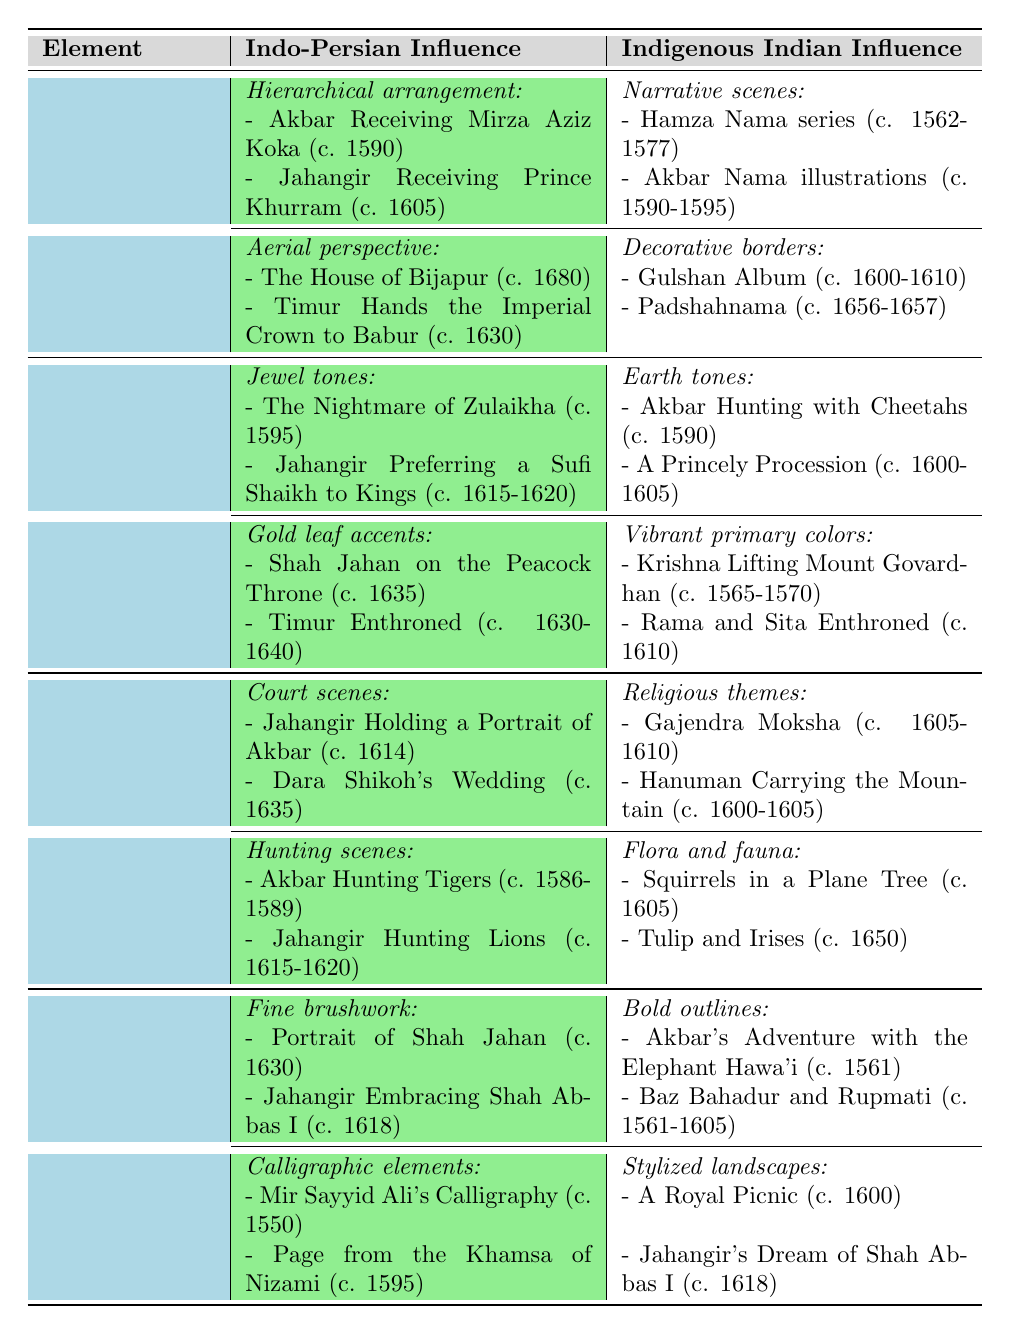What are the main Indo-Persian influences in the composition of Mughal miniature paintings? The table lists two key features under Indo-Persian influence for the composition element: hierarchical arrangement and aerial perspective. These features include specific examples of paintings showcasing these influences.
Answer: Hierarchical arrangement and aerial perspective List one example of indigenous Indian influence in the color palette. The indigenous Indian influence in the color palette includes two features: earth tones and vibrant primary colors. One example under earth tones is "Akbar Hunting with Cheetahs (c. 1590)."
Answer: Akbar Hunting with Cheetahs (c. 1590) How many features of artistic techniques are mentioned in total for both influences? The table lists two features under Indo-Persian influence (fine brushwork and calligraphic elements) and two features under indigenous Indian influence (bold outlines and stylized landscapes), totaling four.
Answer: Four Are there any examples of hunting scenes in indigenous Indian influences? According to the table, indigenous Indian influences in subject matter include religious themes and flora and fauna, but there are no examples of hunting scenes.
Answer: No Which element has more distinct features listed, composition or color palette? The composition element has four features (two from each influence) while the color palette also has four features. Since they are equal, the answer will reflect that.
Answer: They have the same number of features Compare the examples given for the Indo-Persian influence in composition and subject matter in terms of the variety of themes. The Indo-Persian influence for composition includes hierarchical arrangement and aerial perspective, which are both focused on structural and visual techniques. For subject matter, it includes court and hunting scenes, which present a wider variety of themes in narrative context. Thus, subject matter has more thematic variety than composition.
Answer: Subject matter has more thematic variety What is the most common subject matter depicted in Mughal miniature paintings based on the table? The table lists two distinct categories under subject matter for both influences, with hunting scenes and court scenes among the Indo-Persian influences. Therefore, both court and hunting scenes can be considered common representations.
Answer: Court scenes and hunting scenes Identify one technique that is exclusively visible under indigenous Indian influence in the table. The indigenous Indian influence lists bold outlines and stylized landscapes as techniques. Among these, bold outlines are highlighted specifically for indigenous influences.
Answer: Bold outlines What percentage of the examples under Indo-Persian influence in the artistic techniques section includes fine brushwork? There are four examples listed under Indo-Persian influence: two for fine brushwork and two for calligraphic elements. Therefore, fine brushwork makes up 50% of the examples in that section.
Answer: 50% Are there any examples of royal gatherings mentioned under any element, and if so, which one? The subject matter under Indo-Persian influence lists court scenes, one of which is "Dara Shikoh's Wedding," indicating a royal gathering. Thus, yes, there is an example.
Answer: Yes, under subject matter Which painting illustrates the use of gold leaf accents in the color palette? The table specifies "Shah Jahan on the Peacock Throne (c. 1635)" as an example of the use of gold leaf accents under Indo-Persian influences in the color palette.
Answer: Shah Jahan on the Peacock Throne (c. 1635) 